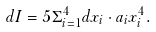<formula> <loc_0><loc_0><loc_500><loc_500>d I = 5 \Sigma _ { i = 1 } ^ { 4 } d x _ { i } \cdot a _ { i } x _ { i } ^ { 4 } .</formula> 